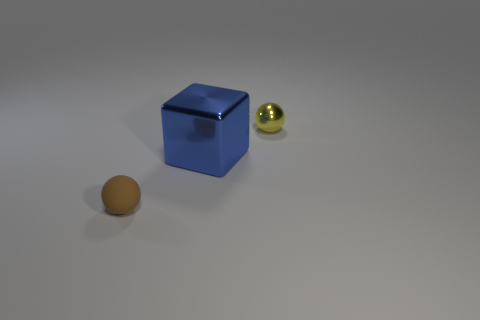How many things are either things that are left of the blue cube or large blue blocks?
Make the answer very short. 2. What is the size of the other thing that is made of the same material as the big blue thing?
Offer a terse response. Small. What number of shiny objects are the same color as the block?
Your response must be concise. 0. How many big things are either brown rubber spheres or yellow metallic spheres?
Provide a succinct answer. 0. Is there a small object that has the same material as the small yellow ball?
Ensure brevity in your answer.  No. There is a sphere in front of the yellow sphere; what is its material?
Your response must be concise. Rubber. Does the shiny thing that is left of the yellow object have the same color as the tiny ball on the left side of the small metal thing?
Provide a short and direct response. No. There is a sphere that is the same size as the brown thing; what color is it?
Make the answer very short. Yellow. How many other things are there of the same shape as the big blue shiny object?
Give a very brief answer. 0. How big is the matte sphere that is left of the small metallic object?
Your answer should be compact. Small. 